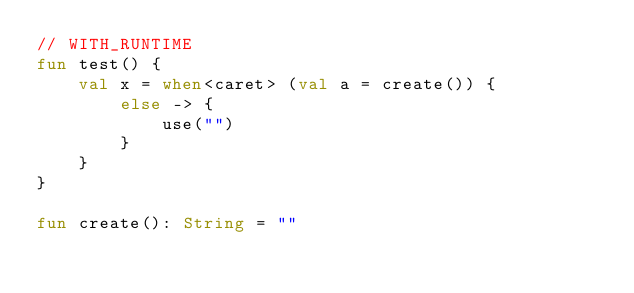<code> <loc_0><loc_0><loc_500><loc_500><_Kotlin_>// WITH_RUNTIME
fun test() {
    val x = when<caret> (val a = create()) {
        else -> {
            use("")
        }
    }
}

fun create(): String = ""
</code> 